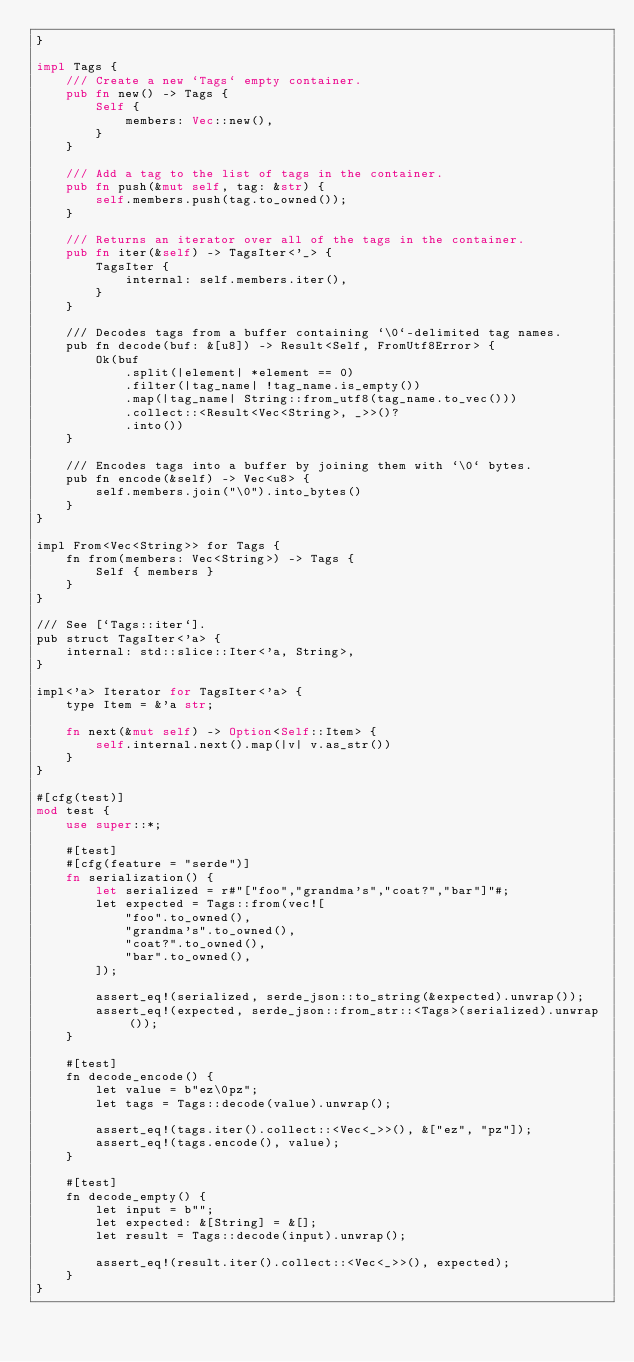<code> <loc_0><loc_0><loc_500><loc_500><_Rust_>}

impl Tags {
    /// Create a new `Tags` empty container.
    pub fn new() -> Tags {
        Self {
            members: Vec::new(),
        }
    }

    /// Add a tag to the list of tags in the container.
    pub fn push(&mut self, tag: &str) {
        self.members.push(tag.to_owned());
    }

    /// Returns an iterator over all of the tags in the container.
    pub fn iter(&self) -> TagsIter<'_> {
        TagsIter {
            internal: self.members.iter(),
        }
    }

    /// Decodes tags from a buffer containing `\0`-delimited tag names.
    pub fn decode(buf: &[u8]) -> Result<Self, FromUtf8Error> {
        Ok(buf
            .split(|element| *element == 0)
            .filter(|tag_name| !tag_name.is_empty())
            .map(|tag_name| String::from_utf8(tag_name.to_vec()))
            .collect::<Result<Vec<String>, _>>()?
            .into())
    }

    /// Encodes tags into a buffer by joining them with `\0` bytes.
    pub fn encode(&self) -> Vec<u8> {
        self.members.join("\0").into_bytes()
    }
}

impl From<Vec<String>> for Tags {
    fn from(members: Vec<String>) -> Tags {
        Self { members }
    }
}

/// See [`Tags::iter`].
pub struct TagsIter<'a> {
    internal: std::slice::Iter<'a, String>,
}

impl<'a> Iterator for TagsIter<'a> {
    type Item = &'a str;

    fn next(&mut self) -> Option<Self::Item> {
        self.internal.next().map(|v| v.as_str())
    }
}

#[cfg(test)]
mod test {
    use super::*;

    #[test]
    #[cfg(feature = "serde")]
    fn serialization() {
        let serialized = r#"["foo","grandma's","coat?","bar"]"#;
        let expected = Tags::from(vec![
            "foo".to_owned(),
            "grandma's".to_owned(),
            "coat?".to_owned(),
            "bar".to_owned(),
        ]);

        assert_eq!(serialized, serde_json::to_string(&expected).unwrap());
        assert_eq!(expected, serde_json::from_str::<Tags>(serialized).unwrap());
    }

    #[test]
    fn decode_encode() {
        let value = b"ez\0pz";
        let tags = Tags::decode(value).unwrap();

        assert_eq!(tags.iter().collect::<Vec<_>>(), &["ez", "pz"]);
        assert_eq!(tags.encode(), value);
    }

    #[test]
    fn decode_empty() {
        let input = b"";
        let expected: &[String] = &[];
        let result = Tags::decode(input).unwrap();

        assert_eq!(result.iter().collect::<Vec<_>>(), expected);
    }
}
</code> 